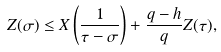Convert formula to latex. <formula><loc_0><loc_0><loc_500><loc_500>Z ( \sigma ) \leq X \left ( \frac { 1 } { \tau - \sigma } \right ) + \frac { q - h } { q } Z ( \tau ) ,</formula> 